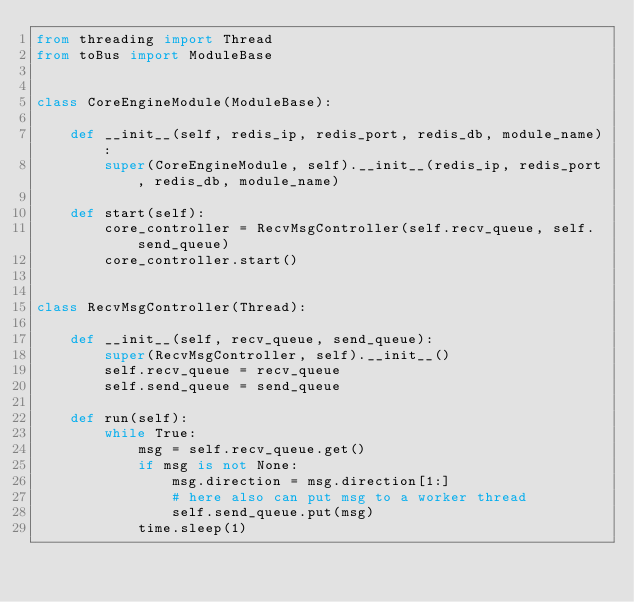Convert code to text. <code><loc_0><loc_0><loc_500><loc_500><_Python_>from threading import Thread
from toBus import ModuleBase


class CoreEngineModule(ModuleBase):

    def __init__(self, redis_ip, redis_port, redis_db, module_name):
        super(CoreEngineModule, self).__init__(redis_ip, redis_port, redis_db, module_name)

    def start(self):
        core_controller = RecvMsgController(self.recv_queue, self.send_queue)
        core_controller.start()


class RecvMsgController(Thread):

    def __init__(self, recv_queue, send_queue):
        super(RecvMsgController, self).__init__()
        self.recv_queue = recv_queue
        self.send_queue = send_queue

    def run(self):
        while True:
            msg = self.recv_queue.get()
            if msg is not None:
                msg.direction = msg.direction[1:]
                # here also can put msg to a worker thread
                self.send_queue.put(msg)
            time.sleep(1)
</code> 